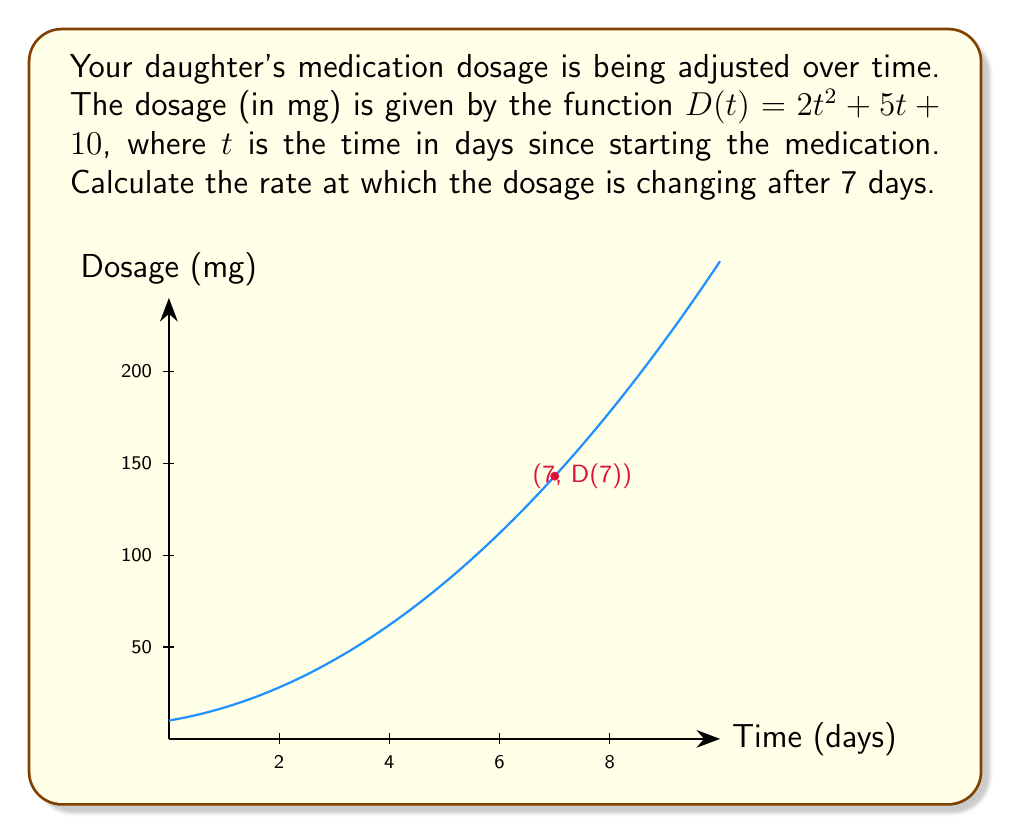Teach me how to tackle this problem. To find the rate of change of the dosage after 7 days, we need to calculate the derivative of the function $D(t)$ and evaluate it at $t=7$. Let's proceed step by step:

1) The given function is $D(t) = 2t^2 + 5t + 10$

2) To find the derivative, we apply the power rule and constant rule:
   $$\frac{d}{dt}(2t^2) = 2 \cdot 2t = 4t$$
   $$\frac{d}{dt}(5t) = 5$$
   $$\frac{d}{dt}(10) = 0$$

3) Combining these results, we get the derivative function:
   $$D'(t) = 4t + 5$$

4) Now, we evaluate $D'(t)$ at $t=7$:
   $$D'(7) = 4(7) + 5 = 28 + 5 = 33$$

Therefore, after 7 days, the dosage is changing at a rate of 33 mg per day.
Answer: $33$ mg/day 